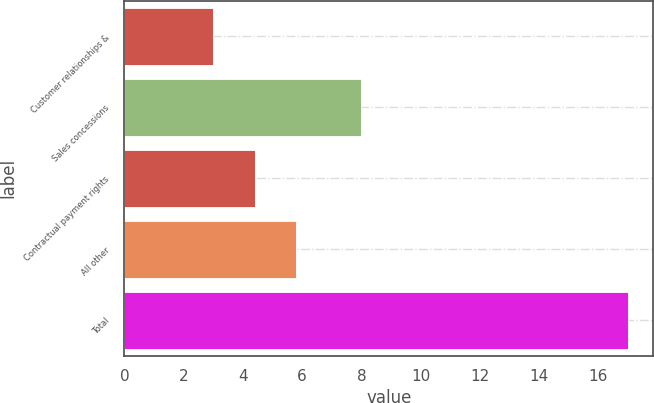Convert chart to OTSL. <chart><loc_0><loc_0><loc_500><loc_500><bar_chart><fcel>Customer relationships &<fcel>Sales concessions<fcel>Contractual payment rights<fcel>All other<fcel>Total<nl><fcel>3<fcel>8<fcel>4.4<fcel>5.8<fcel>17<nl></chart> 